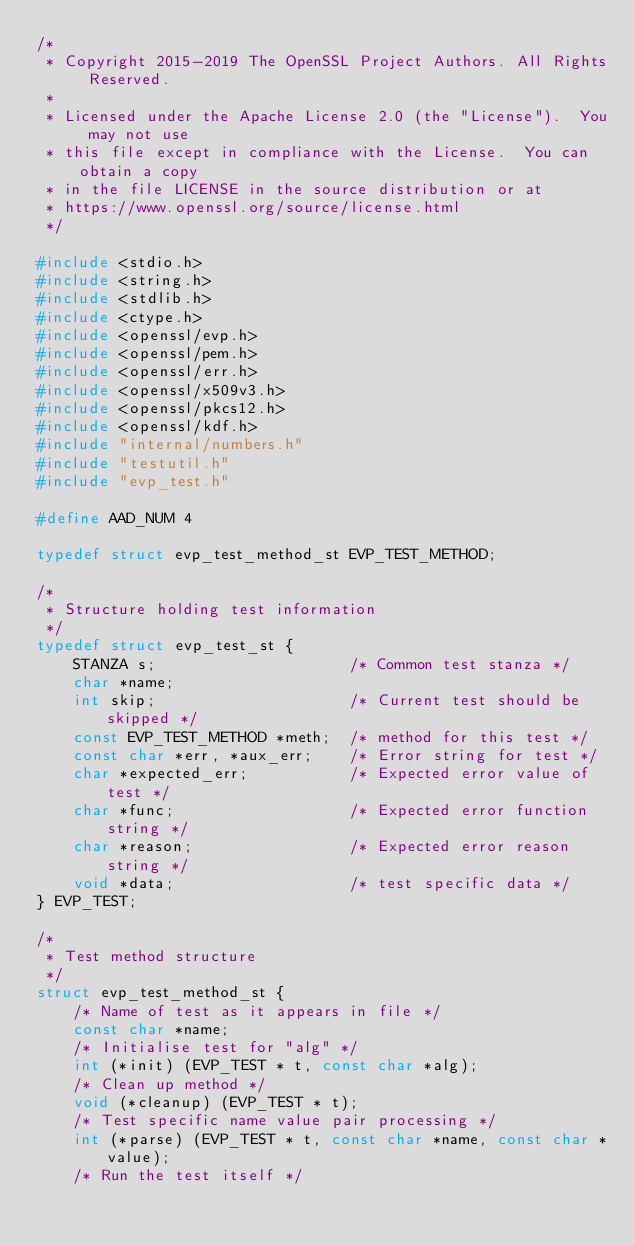<code> <loc_0><loc_0><loc_500><loc_500><_C_>/*
 * Copyright 2015-2019 The OpenSSL Project Authors. All Rights Reserved.
 *
 * Licensed under the Apache License 2.0 (the "License").  You may not use
 * this file except in compliance with the License.  You can obtain a copy
 * in the file LICENSE in the source distribution or at
 * https://www.openssl.org/source/license.html
 */

#include <stdio.h>
#include <string.h>
#include <stdlib.h>
#include <ctype.h>
#include <openssl/evp.h>
#include <openssl/pem.h>
#include <openssl/err.h>
#include <openssl/x509v3.h>
#include <openssl/pkcs12.h>
#include <openssl/kdf.h>
#include "internal/numbers.h"
#include "testutil.h"
#include "evp_test.h"

#define AAD_NUM 4

typedef struct evp_test_method_st EVP_TEST_METHOD;

/*
 * Structure holding test information
 */
typedef struct evp_test_st {
    STANZA s;                     /* Common test stanza */
    char *name;
    int skip;                     /* Current test should be skipped */
    const EVP_TEST_METHOD *meth;  /* method for this test */
    const char *err, *aux_err;    /* Error string for test */
    char *expected_err;           /* Expected error value of test */
    char *func;                   /* Expected error function string */
    char *reason;                 /* Expected error reason string */
    void *data;                   /* test specific data */
} EVP_TEST;

/*
 * Test method structure
 */
struct evp_test_method_st {
    /* Name of test as it appears in file */
    const char *name;
    /* Initialise test for "alg" */
    int (*init) (EVP_TEST * t, const char *alg);
    /* Clean up method */
    void (*cleanup) (EVP_TEST * t);
    /* Test specific name value pair processing */
    int (*parse) (EVP_TEST * t, const char *name, const char *value);
    /* Run the test itself */</code> 